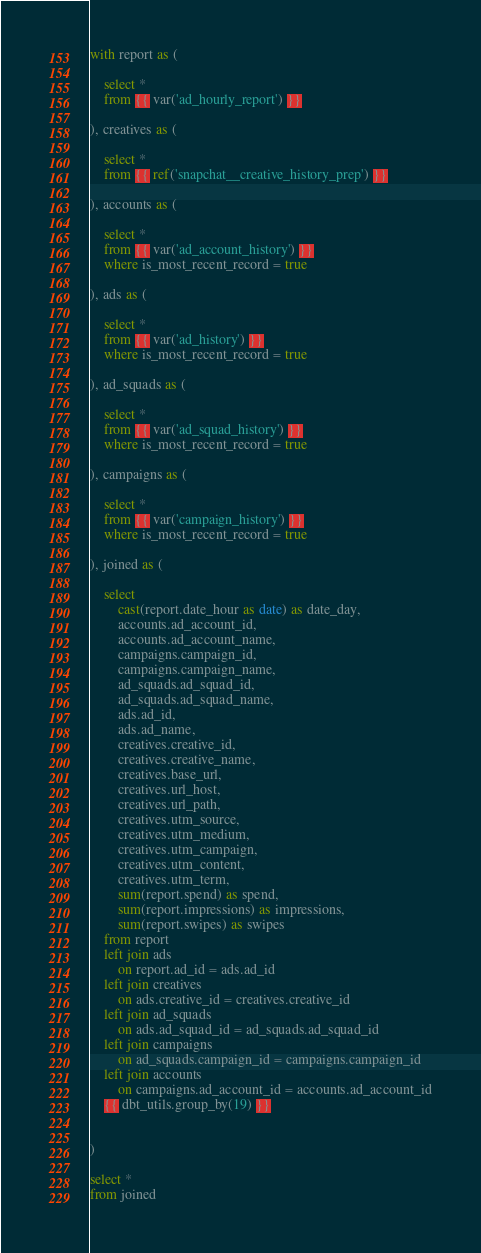<code> <loc_0><loc_0><loc_500><loc_500><_SQL_>with report as (

    select *
    from {{ var('ad_hourly_report') }}

), creatives as (

    select *
    from {{ ref('snapchat__creative_history_prep') }}

), accounts as (

    select *
    from {{ var('ad_account_history') }}
    where is_most_recent_record = true

), ads as (

    select *
    from {{ var('ad_history') }}
    where is_most_recent_record = true

), ad_squads as (

    select *
    from {{ var('ad_squad_history') }}
    where is_most_recent_record = true

), campaigns as (

    select *
    from {{ var('campaign_history') }}
    where is_most_recent_record = true

), joined as (

    select
        cast(report.date_hour as date) as date_day,
        accounts.ad_account_id,
        accounts.ad_account_name,
        campaigns.campaign_id,
        campaigns.campaign_name,
        ad_squads.ad_squad_id,
        ad_squads.ad_squad_name,
        ads.ad_id,
        ads.ad_name,
        creatives.creative_id,
        creatives.creative_name,
        creatives.base_url,
        creatives.url_host,
        creatives.url_path,
        creatives.utm_source,
        creatives.utm_medium,
        creatives.utm_campaign,
        creatives.utm_content,
        creatives.utm_term,
        sum(report.spend) as spend,
        sum(report.impressions) as impressions,
        sum(report.swipes) as swipes
    from report
    left join ads 
        on report.ad_id = ads.ad_id
    left join creatives
        on ads.creative_id = creatives.creative_id
    left join ad_squads
        on ads.ad_squad_id = ad_squads.ad_squad_id
    left join campaigns
        on ad_squads.campaign_id = campaigns.campaign_id
    left join accounts
        on campaigns.ad_account_id = accounts.ad_account_id
    {{ dbt_utils.group_by(19) }}


)

select *
from joined</code> 